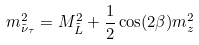<formula> <loc_0><loc_0><loc_500><loc_500>m _ { \tilde { \nu } _ { \tau } } ^ { 2 } = M _ { \tilde { L } } ^ { 2 } + \frac { 1 } { 2 } \cos ( 2 \beta ) m _ { z } ^ { 2 }</formula> 